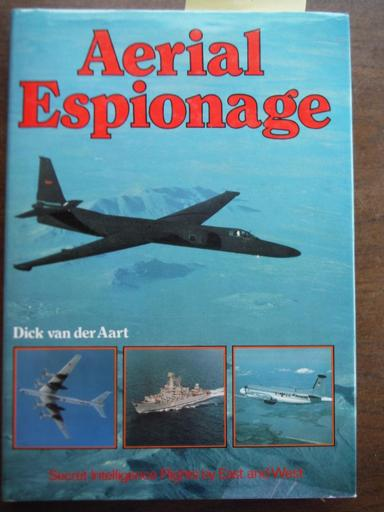Can you tell me more about the historical context of aerial espionage practices mentioned in this book? The book 'Aerial Espionage' covers a critical examination of the cold war era, when aerial surveillance technology rapidly evolved. It details how different countries developed advanced aircraft to gather intelligence over hostile territories without being detected, playing a crucial role in maintaining a balance of power during tense geopolitical times. 